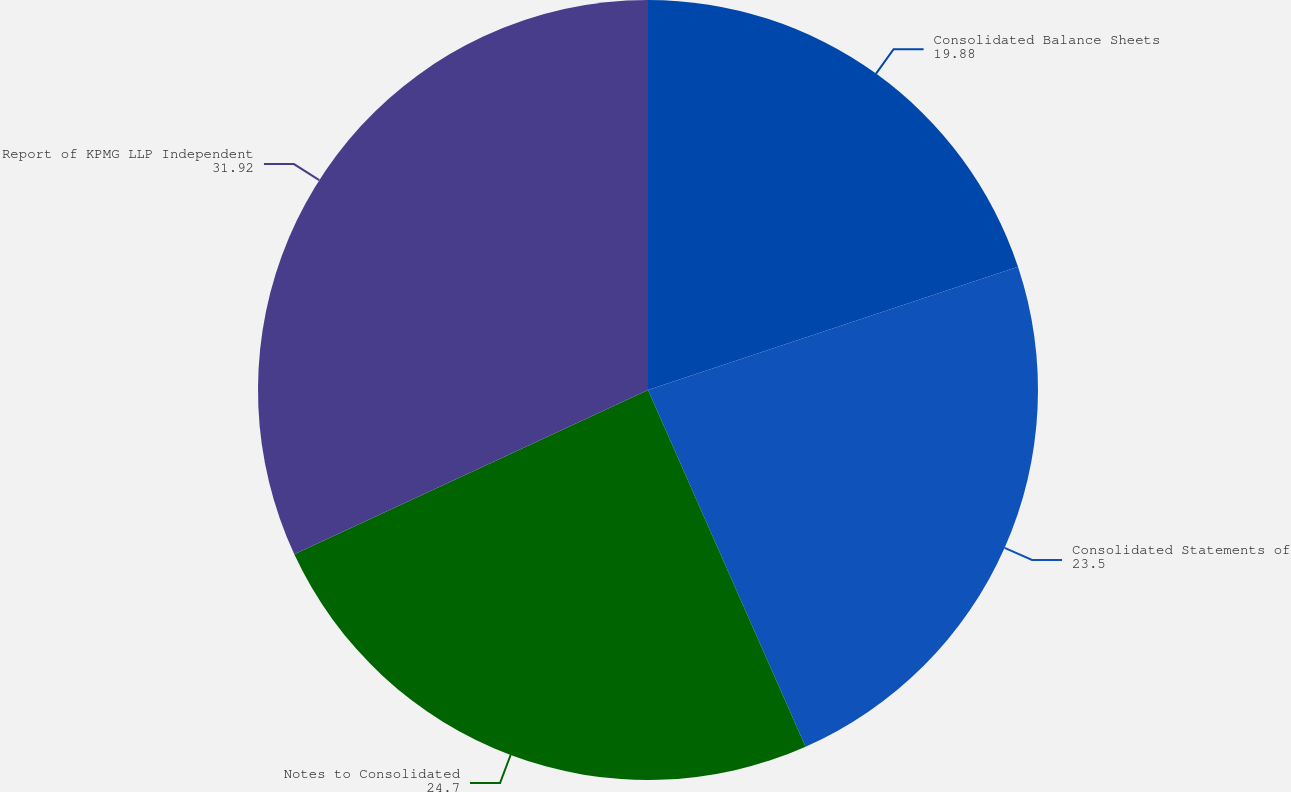Convert chart to OTSL. <chart><loc_0><loc_0><loc_500><loc_500><pie_chart><fcel>Consolidated Balance Sheets<fcel>Consolidated Statements of<fcel>Notes to Consolidated<fcel>Report of KPMG LLP Independent<nl><fcel>19.88%<fcel>23.5%<fcel>24.7%<fcel>31.92%<nl></chart> 